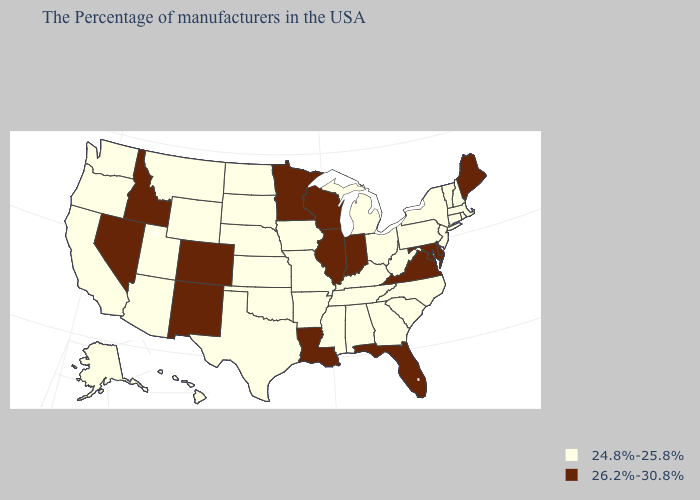Name the states that have a value in the range 26.2%-30.8%?
Keep it brief. Maine, Delaware, Maryland, Virginia, Florida, Indiana, Wisconsin, Illinois, Louisiana, Minnesota, Colorado, New Mexico, Idaho, Nevada. Name the states that have a value in the range 26.2%-30.8%?
Short answer required. Maine, Delaware, Maryland, Virginia, Florida, Indiana, Wisconsin, Illinois, Louisiana, Minnesota, Colorado, New Mexico, Idaho, Nevada. Name the states that have a value in the range 24.8%-25.8%?
Answer briefly. Massachusetts, Rhode Island, New Hampshire, Vermont, Connecticut, New York, New Jersey, Pennsylvania, North Carolina, South Carolina, West Virginia, Ohio, Georgia, Michigan, Kentucky, Alabama, Tennessee, Mississippi, Missouri, Arkansas, Iowa, Kansas, Nebraska, Oklahoma, Texas, South Dakota, North Dakota, Wyoming, Utah, Montana, Arizona, California, Washington, Oregon, Alaska, Hawaii. Does Wisconsin have a lower value than Ohio?
Short answer required. No. Does Indiana have the lowest value in the USA?
Quick response, please. No. Name the states that have a value in the range 24.8%-25.8%?
Give a very brief answer. Massachusetts, Rhode Island, New Hampshire, Vermont, Connecticut, New York, New Jersey, Pennsylvania, North Carolina, South Carolina, West Virginia, Ohio, Georgia, Michigan, Kentucky, Alabama, Tennessee, Mississippi, Missouri, Arkansas, Iowa, Kansas, Nebraska, Oklahoma, Texas, South Dakota, North Dakota, Wyoming, Utah, Montana, Arizona, California, Washington, Oregon, Alaska, Hawaii. Among the states that border Nevada , which have the highest value?
Keep it brief. Idaho. Which states have the lowest value in the USA?
Concise answer only. Massachusetts, Rhode Island, New Hampshire, Vermont, Connecticut, New York, New Jersey, Pennsylvania, North Carolina, South Carolina, West Virginia, Ohio, Georgia, Michigan, Kentucky, Alabama, Tennessee, Mississippi, Missouri, Arkansas, Iowa, Kansas, Nebraska, Oklahoma, Texas, South Dakota, North Dakota, Wyoming, Utah, Montana, Arizona, California, Washington, Oregon, Alaska, Hawaii. What is the highest value in states that border New York?
Short answer required. 24.8%-25.8%. Among the states that border Missouri , does Iowa have the highest value?
Give a very brief answer. No. What is the highest value in the USA?
Quick response, please. 26.2%-30.8%. Among the states that border Washington , does Idaho have the lowest value?
Answer briefly. No. Does the map have missing data?
Short answer required. No. Among the states that border Montana , which have the highest value?
Short answer required. Idaho. What is the value of North Carolina?
Answer briefly. 24.8%-25.8%. 